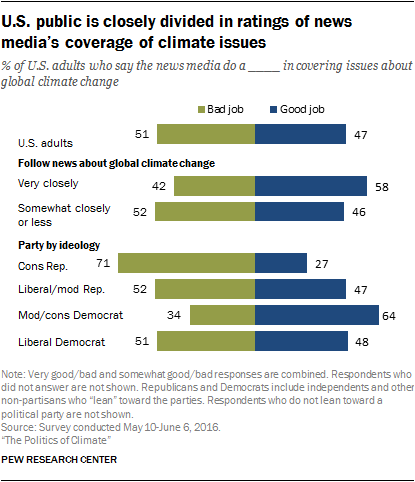Specify some key components in this picture. About 51% of U.S. adults have an unfavorable opinion of their job. The ratio of the smallest blue bar to the first green bar from the top is 1.160416667... 